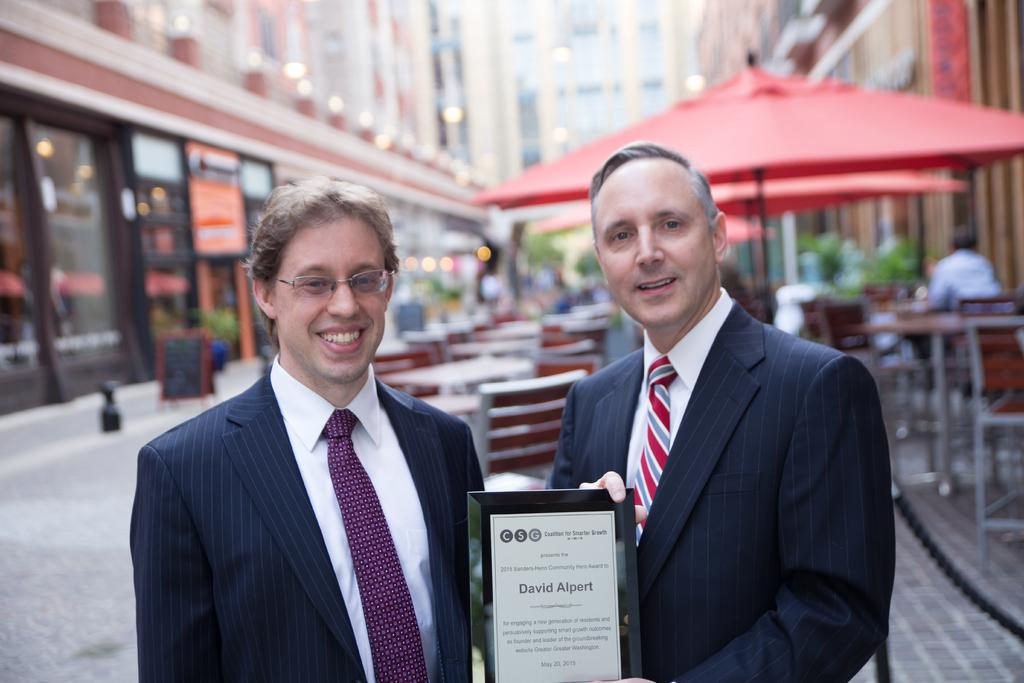How many men are present in the image? There are two men standing in the image. What are the men holding in the image? The men are holding an award. What type of furniture can be seen in the background of the image? There are chairs and tables in the background of the image. What objects are present in the background of the image that might provide shelter or protection from the elements? There are umbrellas in the background of the image. What type of structures are visible in the background of the image? There are buildings in the background of the image. Where is the faucet located in the image? There is no faucet present in the image. What type of button can be seen on the men's clothing in the image? There is no button visible on the men's clothing in the image. 